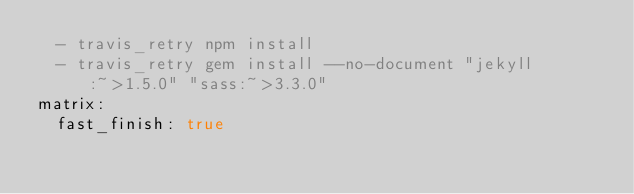Convert code to text. <code><loc_0><loc_0><loc_500><loc_500><_YAML_>  - travis_retry npm install
  - travis_retry gem install --no-document "jekyll:~>1.5.0" "sass:~>3.3.0"
matrix:
  fast_finish: true
</code> 